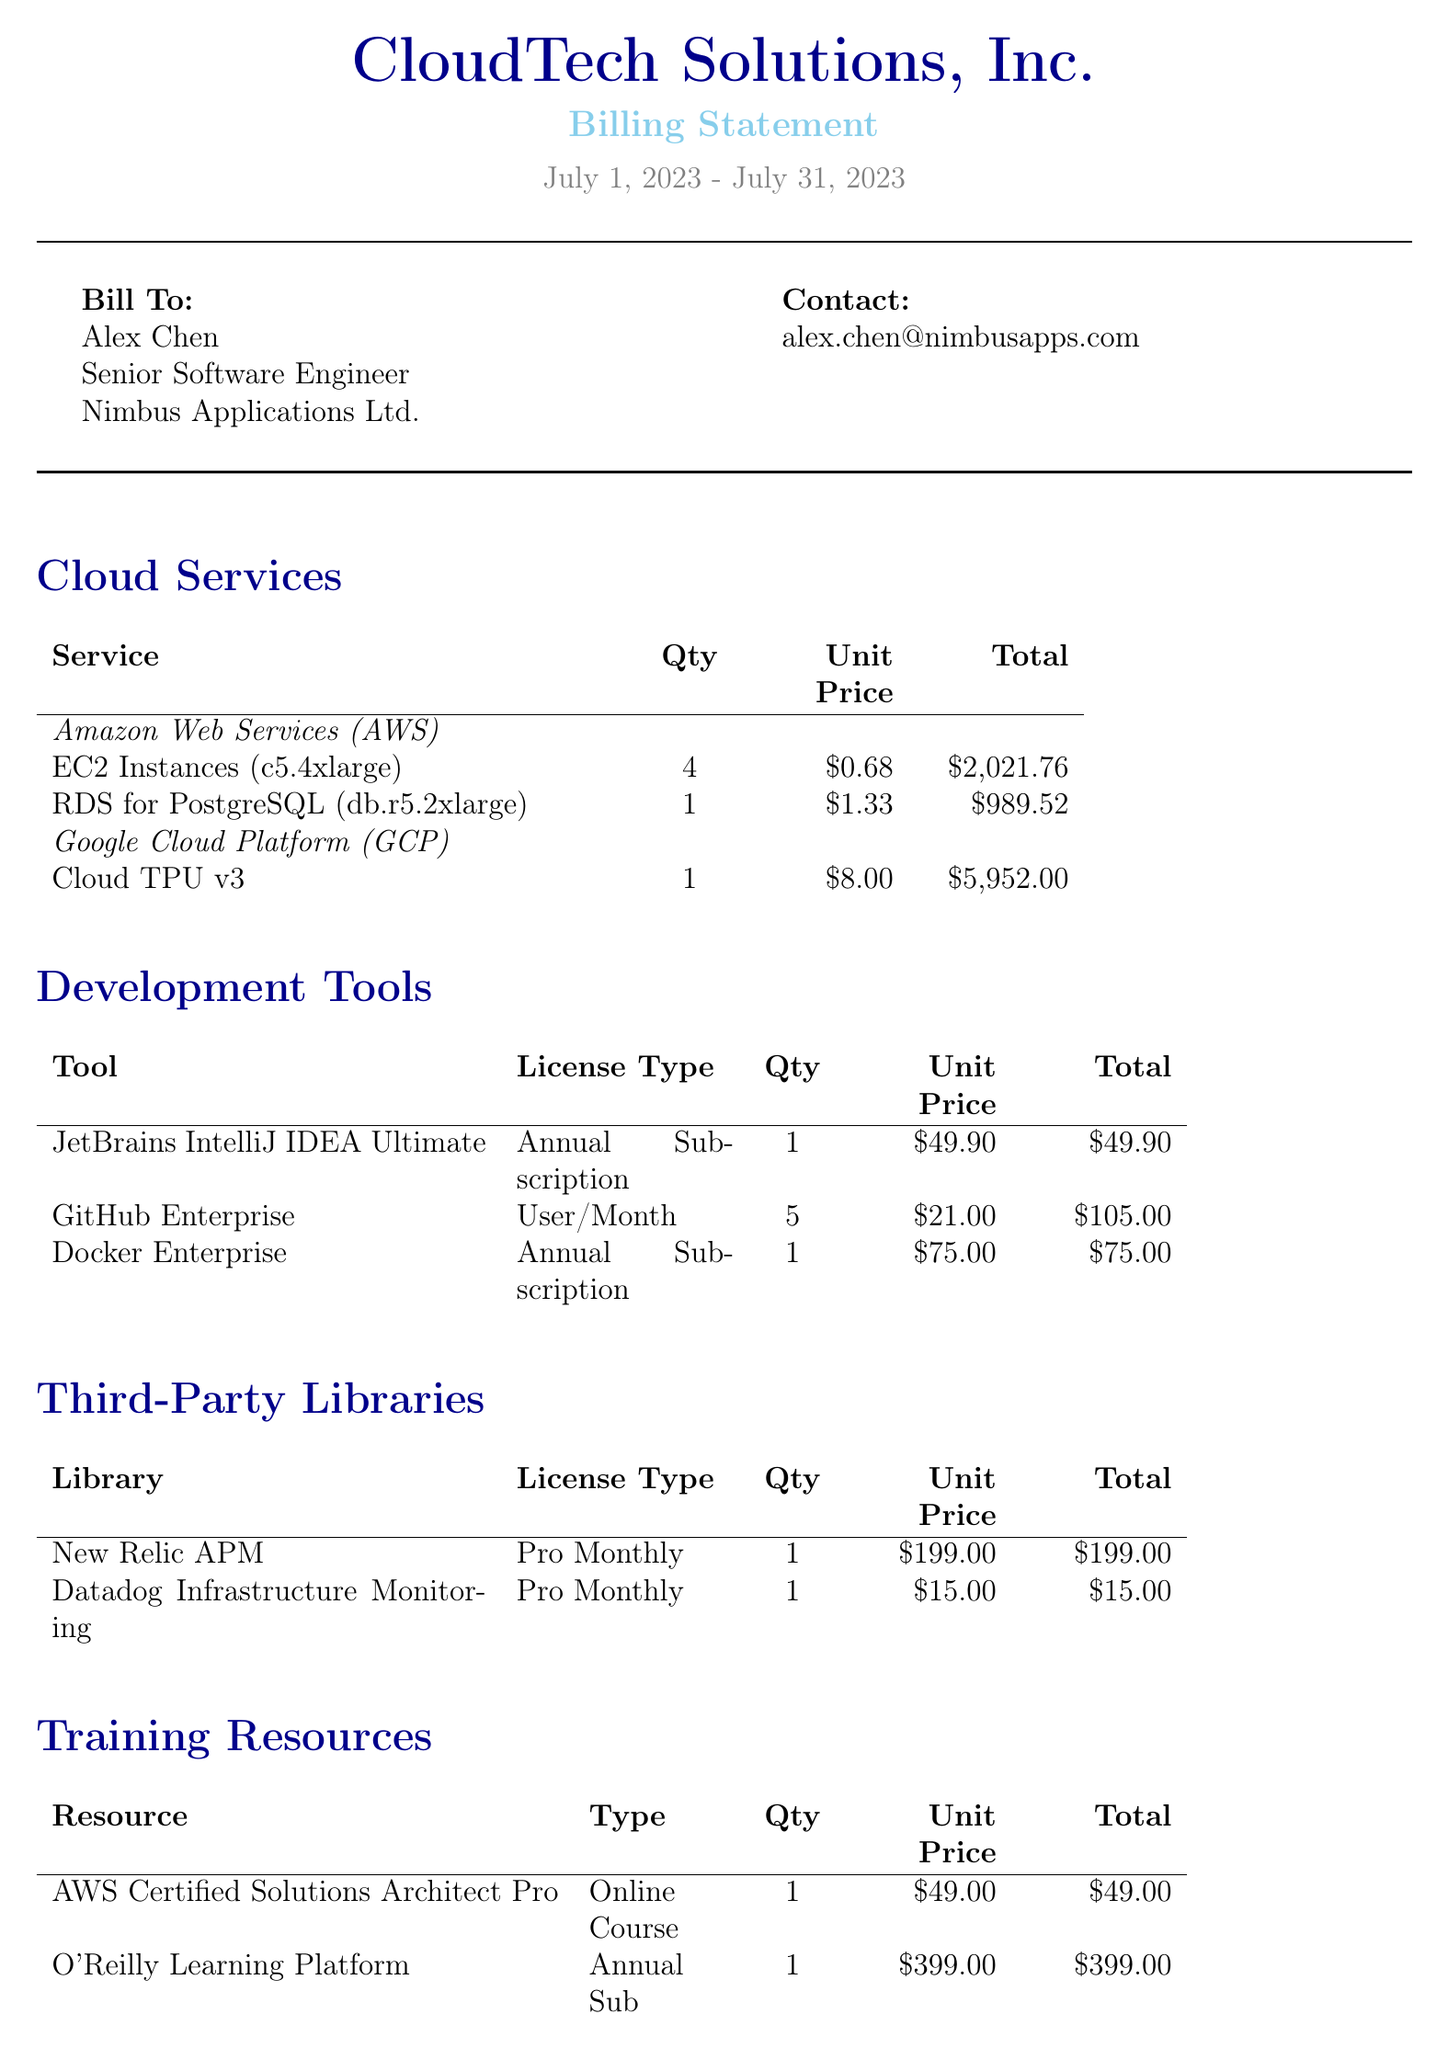What is the company name? The company name is stated at the beginning of the document.
Answer: CloudTech Solutions, Inc What is the billing period? The billing period indicates the timeframe for which the bill is generated, found near the top of the document.
Answer: July 1, 2023 - July 31, 2023 Who is the customer? The customer's name and company are provided in the "Bill To" section.
Answer: Alex Chen What is the total amount due? The total amount is highlighted at the end of the document, summarizing the subtotal, tax, and total.
Answer: $14628.02 How many NVIDIA Tesla V100 GPUs were rented? The quantity of this hardware rental is provided in the "Hardware" section of the document.
Answer: 2 What is the unit price of GitHub Enterprise? The unit price for this development tool is specified in the "Development Tools" section of the document.
Answer: $21.00 What is the tax rate? The tax rate is mentioned near the total calculation section of the document.
Answer: 8% What type of license is associated with JetBrains IntelliJ IDEA Ultimate? The license type for this development tool is explained in the corresponding section of the document.
Answer: Annual Subscription What payment methods are accepted? The payment methods are listed towards the end of the document under payment terms.
Answer: Credit Card, Wire Transfer, ACH 